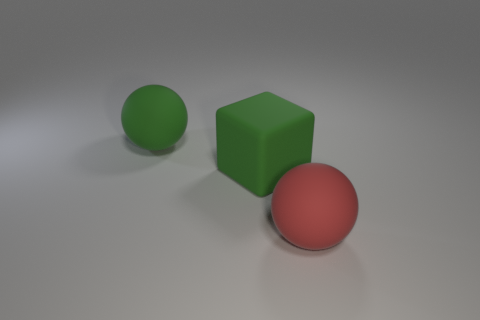Add 3 purple rubber objects. How many objects exist? 6 Subtract all cubes. How many objects are left? 2 Subtract 1 red balls. How many objects are left? 2 Subtract all matte blocks. Subtract all red objects. How many objects are left? 1 Add 2 large rubber spheres. How many large rubber spheres are left? 4 Add 2 red spheres. How many red spheres exist? 3 